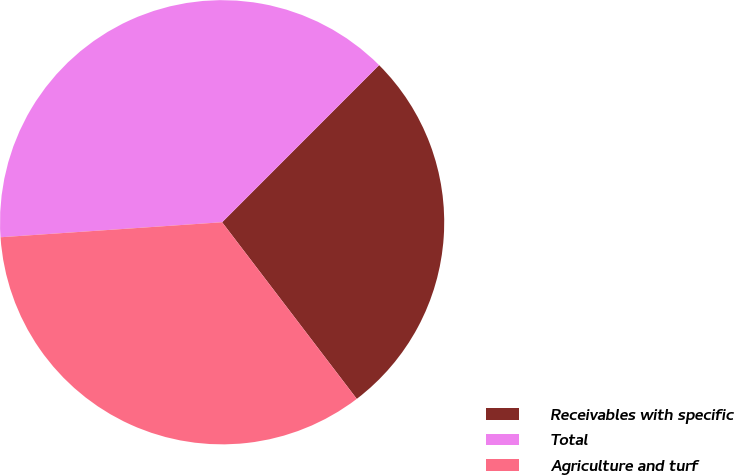Convert chart to OTSL. <chart><loc_0><loc_0><loc_500><loc_500><pie_chart><fcel>Receivables with specific<fcel>Total<fcel>Agriculture and turf<nl><fcel>27.14%<fcel>38.57%<fcel>34.29%<nl></chart> 